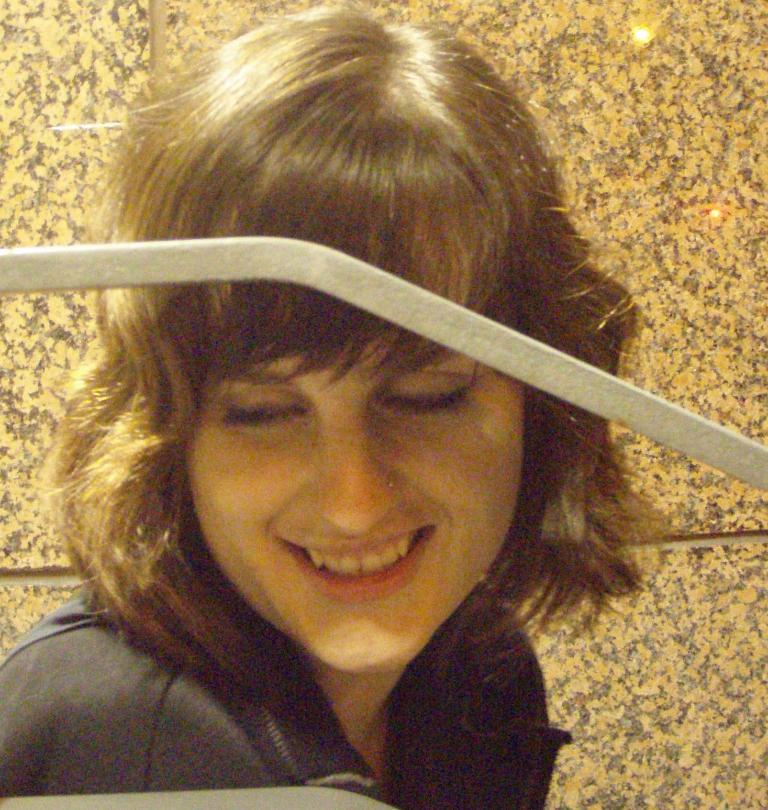What object can be seen in the image? There is a rod in the image. Who is present in the image? There is a woman in the image. What is the woman's expression? The woman is smiling. What can be seen in the background of the image? There is a wall in the background of the image. What type of robin is perched on the woman's shoulder in the image? There is no robin present in the image; it only features a rod and a woman. What type of wine is the woman holding in the image? There is no wine present in the image; the woman is simply smiling. 